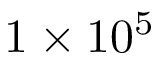Convert formula to latex. <formula><loc_0><loc_0><loc_500><loc_500>1 \times 1 0 ^ { 5 }</formula> 